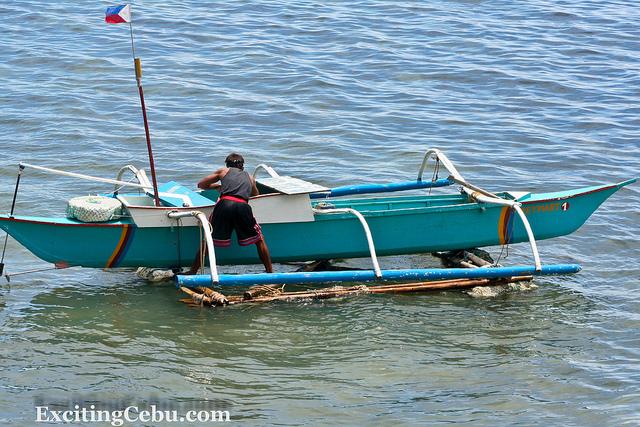What colors are in the flag?
Short answer required. Red, white, and blue. What is the person doing on the side of the boat?
Answer briefly. Putting fish in hold. Is the water matching the boat's color?
Give a very brief answer. Yes. 